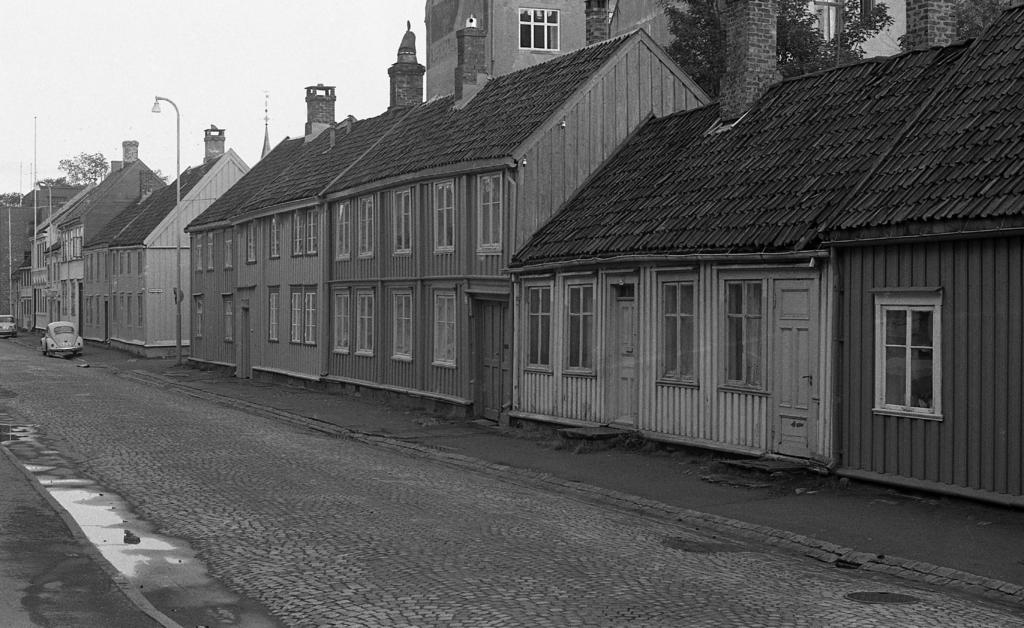What type of structures are located on the right side of the image? There are houses on the right side of the image. What type of vehicles can be seen on the left side of the image? There are cars on the left side of the image. What type of plant is visible at the top side of the image? There is a tree at the top side of the image. How many pets are visible in the image? There are no pets visible in the image. What type of ground is present in the image? The type of ground is not mentioned in the provided facts, so it cannot be determined from the image. 